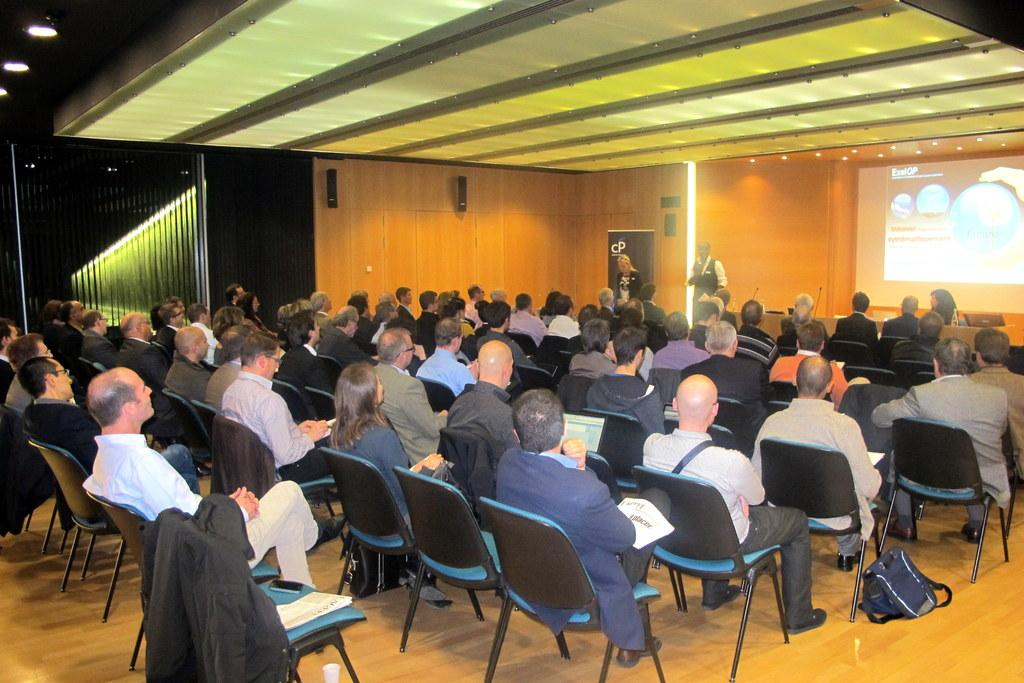How many people are in the image? There is a group of people in the image. What are the people doing in the image? The people are sitting on chairs. What can be seen on the right side of the image? There is a projector screen on the right side of the image. What type of grain is being discussed in the image? There is no mention of grain in the image, as the focus is on the group of people sitting on chairs and the projector screen. 